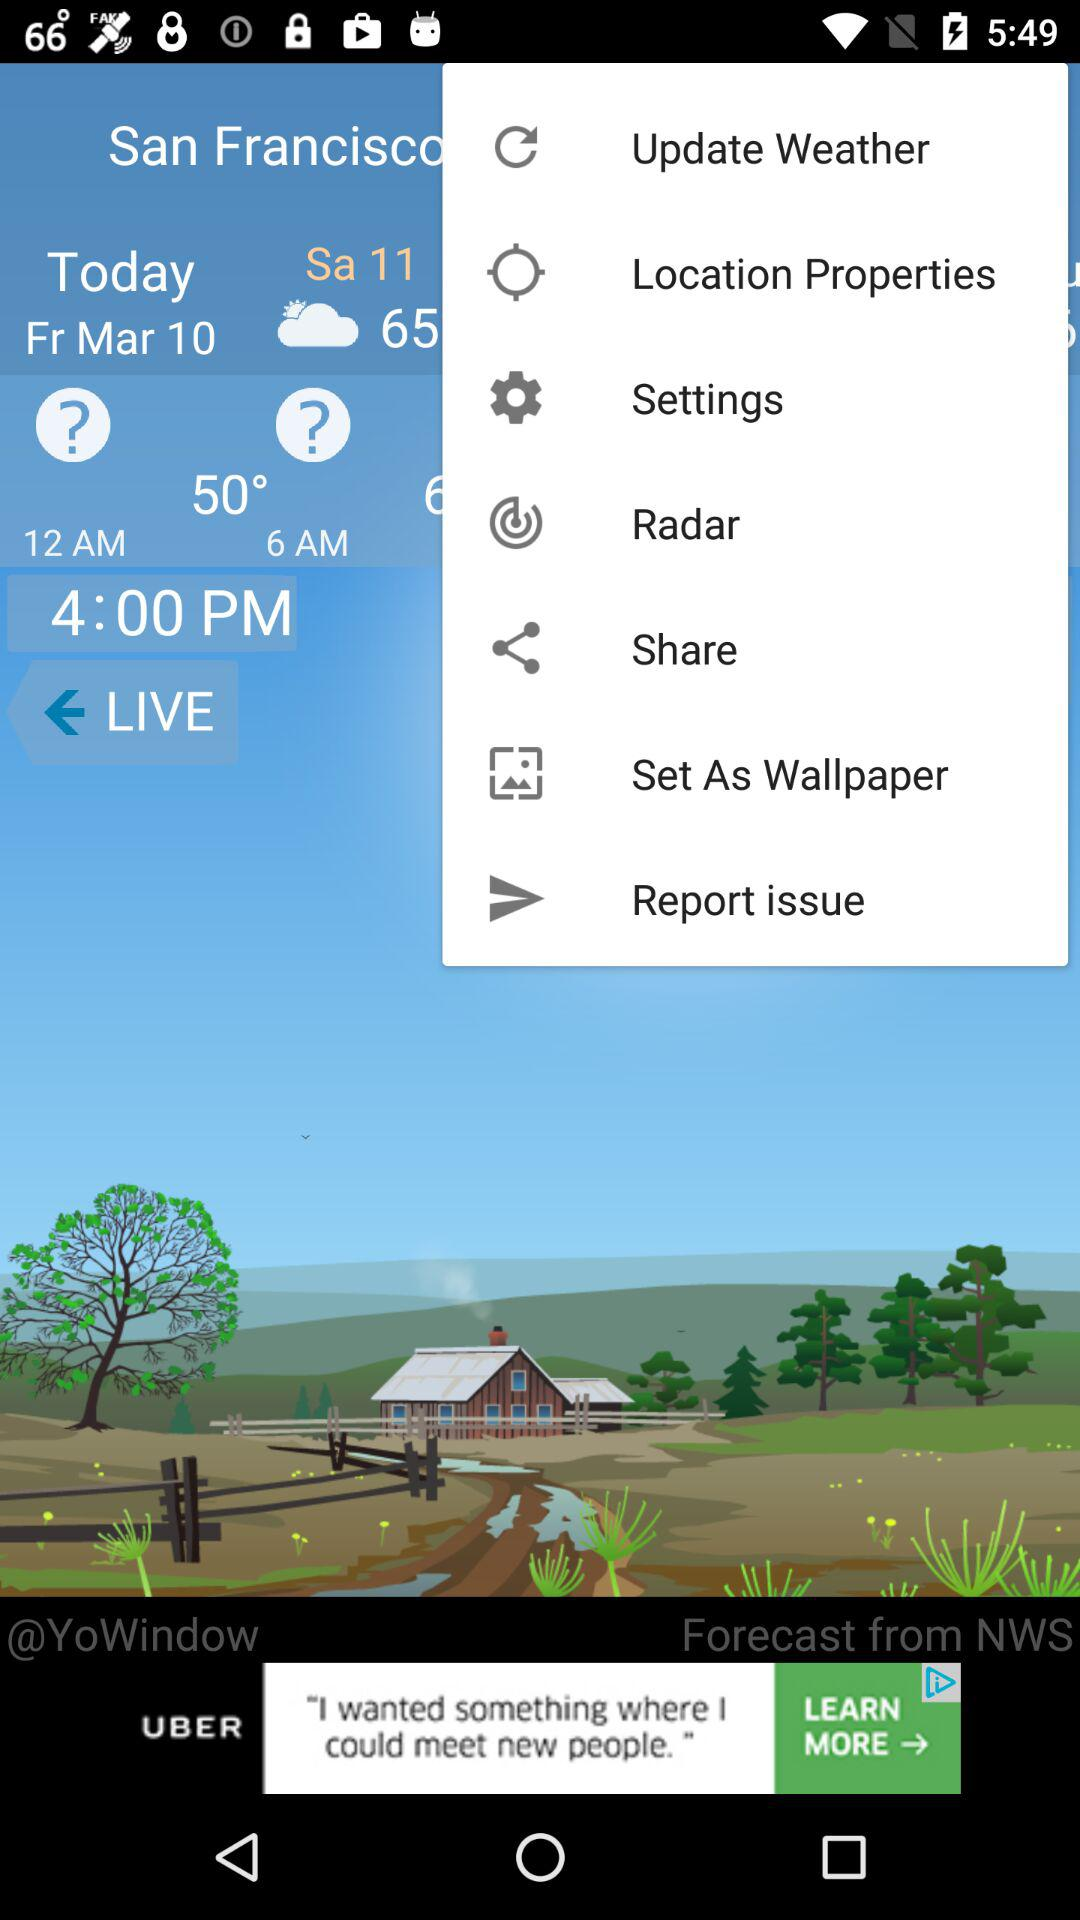What is the current location? The current location is San Francisco. 